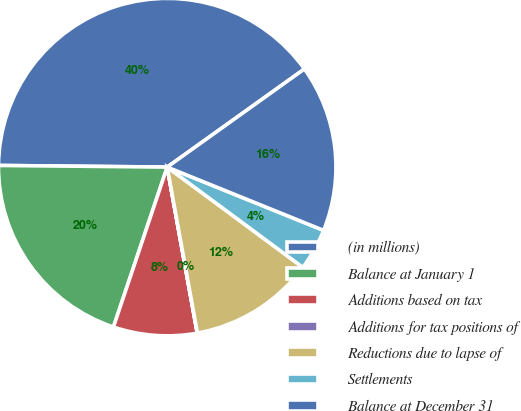Convert chart to OTSL. <chart><loc_0><loc_0><loc_500><loc_500><pie_chart><fcel>(in millions)<fcel>Balance at January 1<fcel>Additions based on tax<fcel>Additions for tax positions of<fcel>Reductions due to lapse of<fcel>Settlements<fcel>Balance at December 31<nl><fcel>39.96%<fcel>19.99%<fcel>8.01%<fcel>0.02%<fcel>12.0%<fcel>4.01%<fcel>16.0%<nl></chart> 